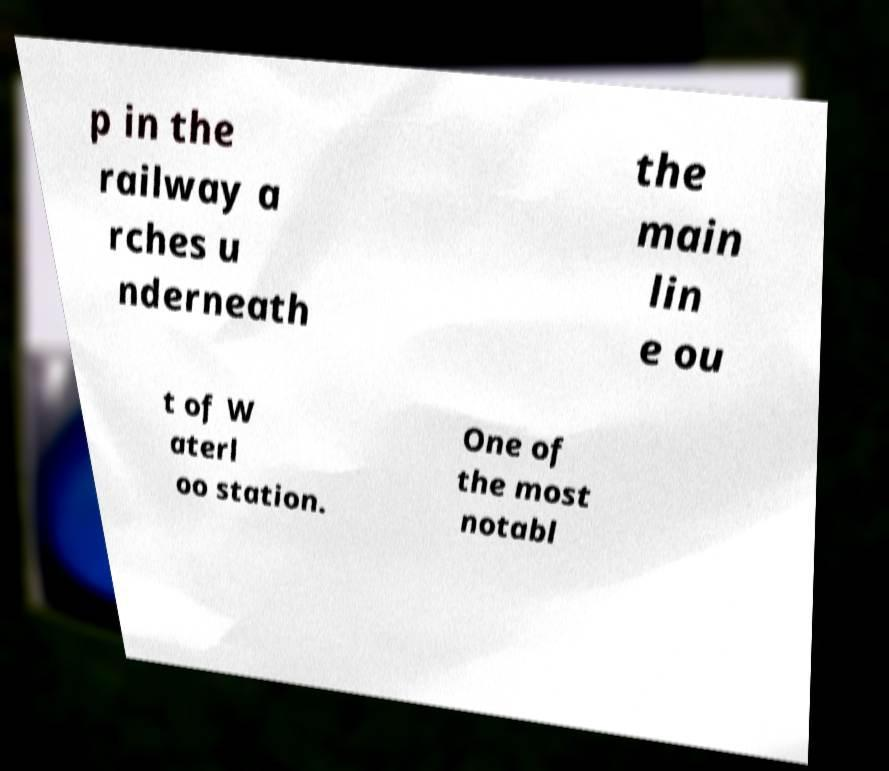Could you assist in decoding the text presented in this image and type it out clearly? p in the railway a rches u nderneath the main lin e ou t of W aterl oo station. One of the most notabl 